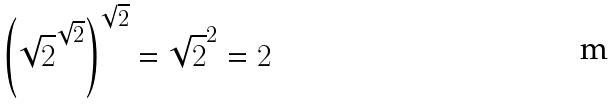Convert formula to latex. <formula><loc_0><loc_0><loc_500><loc_500>\left ( { \sqrt { 2 } } ^ { \sqrt { 2 } } \right ) ^ { \sqrt { 2 } } = { \sqrt { 2 } } ^ { 2 } = 2</formula> 